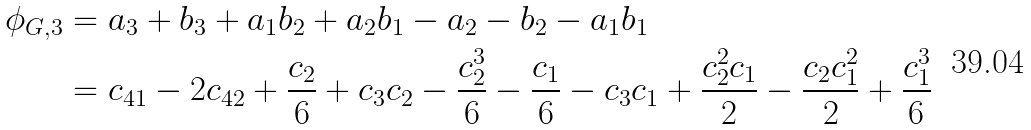Convert formula to latex. <formula><loc_0><loc_0><loc_500><loc_500>\phi _ { G , 3 } & = a _ { 3 } + b _ { 3 } + a _ { 1 } b _ { 2 } + a _ { 2 } b _ { 1 } - a _ { 2 } - b _ { 2 } - a _ { 1 } b _ { 1 } \\ & = c _ { 4 1 } - 2 c _ { 4 2 } + \frac { c _ { 2 } } { 6 } + c _ { 3 } c _ { 2 } - \frac { c _ { 2 } ^ { 3 } } { 6 } - \frac { c _ { 1 } } { 6 } - c _ { 3 } c _ { 1 } + \frac { c _ { 2 } ^ { 2 } c _ { 1 } } { 2 } - \frac { c _ { 2 } c _ { 1 } ^ { 2 } } { 2 } + \frac { c _ { 1 } ^ { 3 } } { 6 }</formula> 